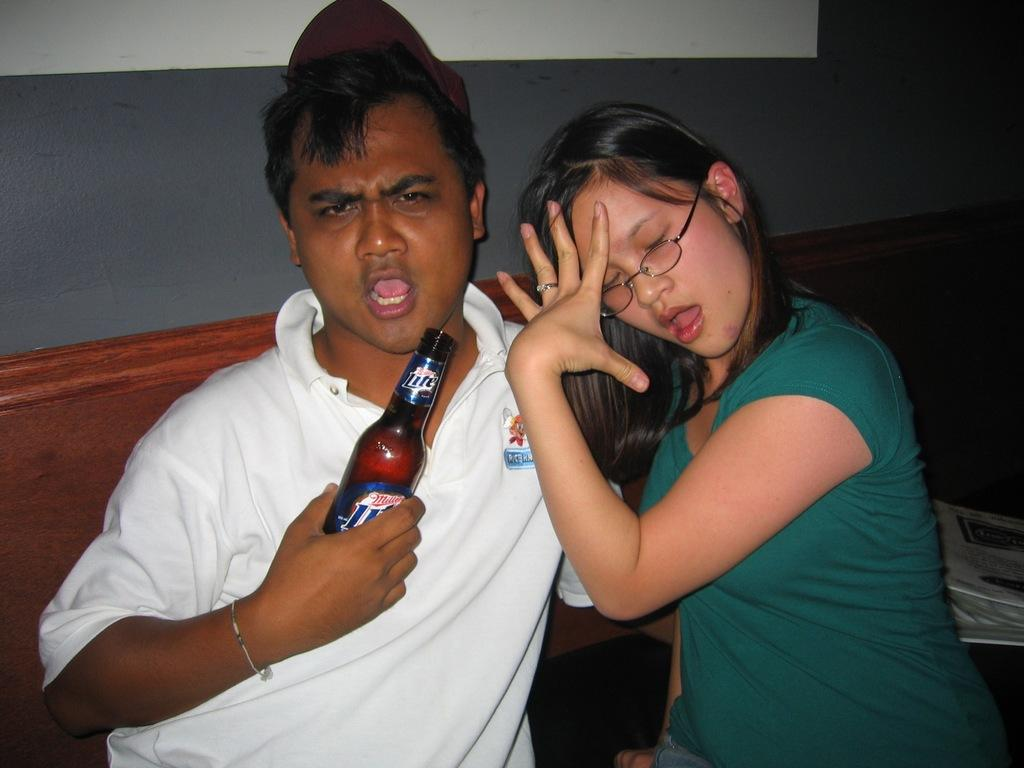What are the two people in the image doing? There is a man and a woman sitting in the image. What is the man holding in the image? The man is holding a bottle in the image. What can be seen in the background of the image? There is a wall visible in the background of the image. How many beans are on the floor in the image? There are no beans present in the image. What type of door can be seen in the image? There is no door visible in the image; only a wall is present in the background. 